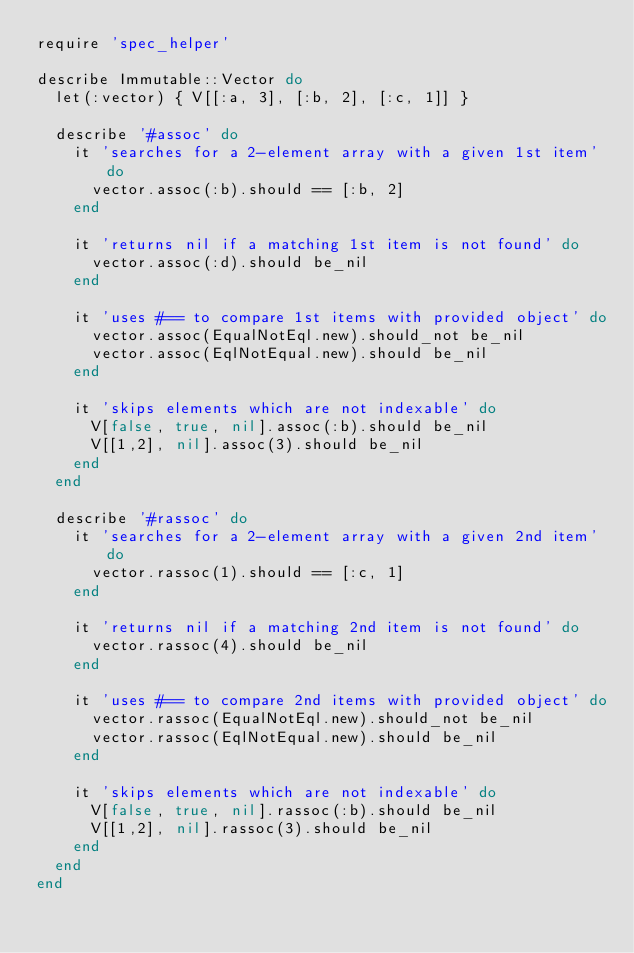<code> <loc_0><loc_0><loc_500><loc_500><_Ruby_>require 'spec_helper'

describe Immutable::Vector do
  let(:vector) { V[[:a, 3], [:b, 2], [:c, 1]] }

  describe '#assoc' do
    it 'searches for a 2-element array with a given 1st item' do
      vector.assoc(:b).should == [:b, 2]
    end

    it 'returns nil if a matching 1st item is not found' do
      vector.assoc(:d).should be_nil
    end

    it 'uses #== to compare 1st items with provided object' do
      vector.assoc(EqualNotEql.new).should_not be_nil
      vector.assoc(EqlNotEqual.new).should be_nil
    end

    it 'skips elements which are not indexable' do
      V[false, true, nil].assoc(:b).should be_nil
      V[[1,2], nil].assoc(3).should be_nil
    end
  end

  describe '#rassoc' do
    it 'searches for a 2-element array with a given 2nd item' do
      vector.rassoc(1).should == [:c, 1]
    end

    it 'returns nil if a matching 2nd item is not found' do
      vector.rassoc(4).should be_nil
    end

    it 'uses #== to compare 2nd items with provided object' do
      vector.rassoc(EqualNotEql.new).should_not be_nil
      vector.rassoc(EqlNotEqual.new).should be_nil
    end

    it 'skips elements which are not indexable' do
      V[false, true, nil].rassoc(:b).should be_nil
      V[[1,2], nil].rassoc(3).should be_nil
    end
  end
end
</code> 